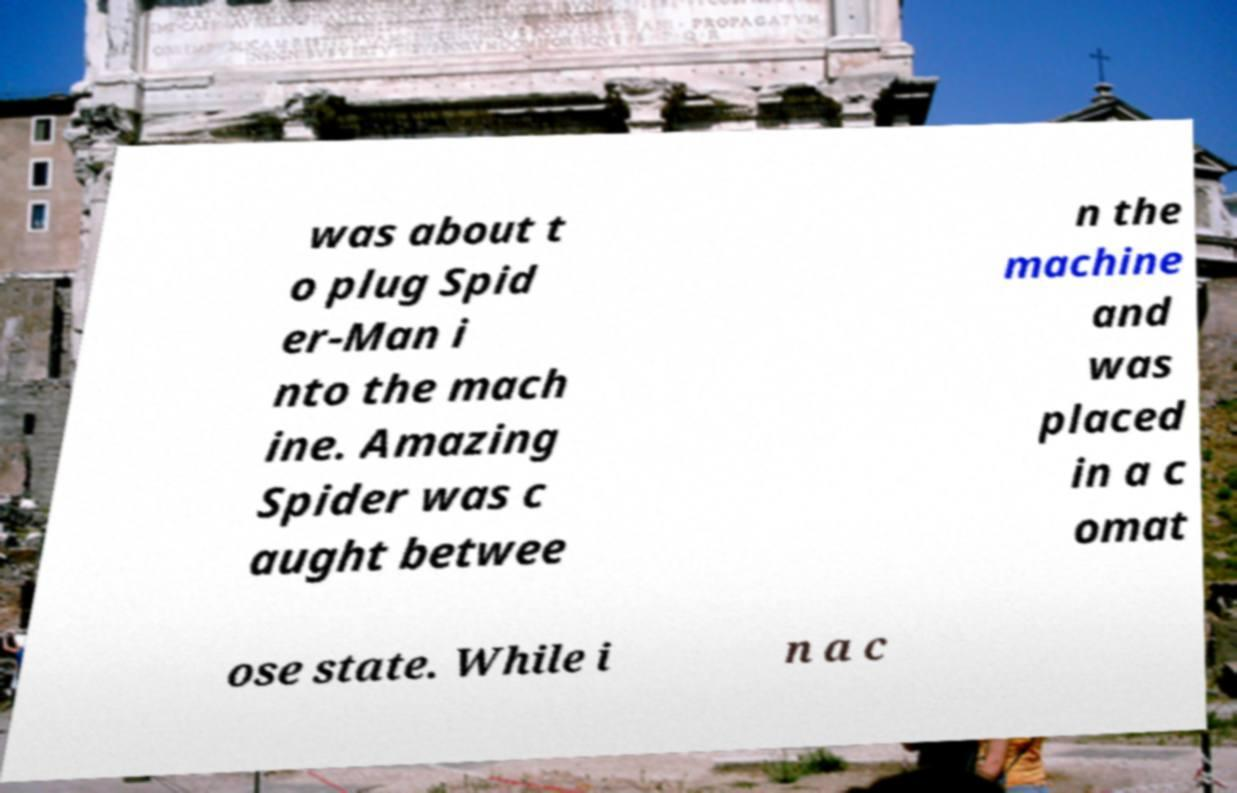Please identify and transcribe the text found in this image. was about t o plug Spid er-Man i nto the mach ine. Amazing Spider was c aught betwee n the machine and was placed in a c omat ose state. While i n a c 